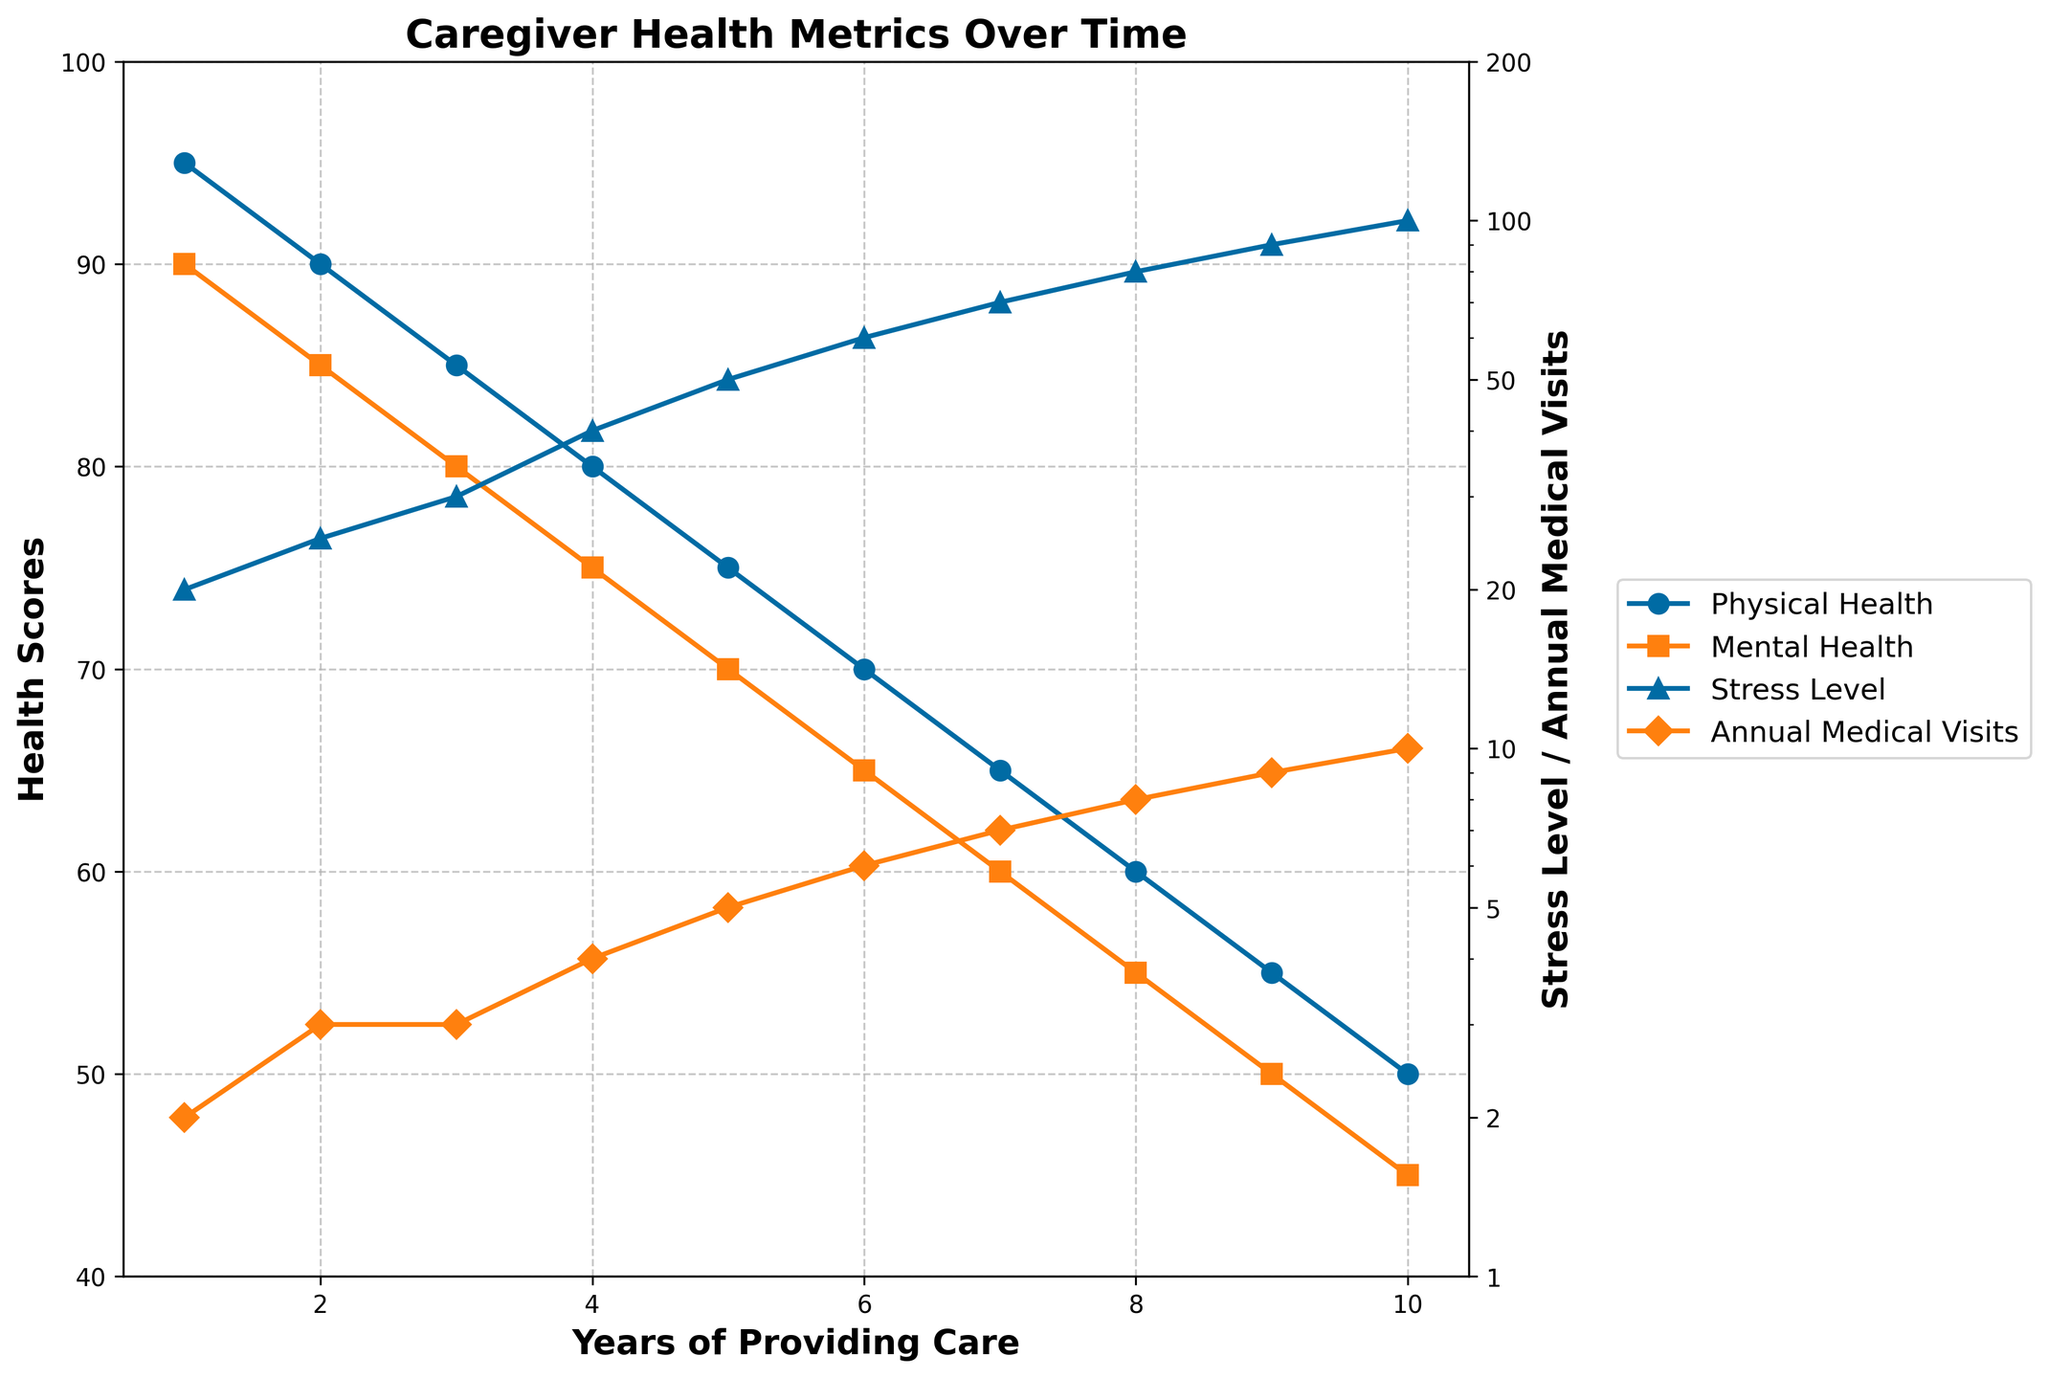What is the title of the plot? The title of the plot is shown at the top of the figure.
Answer: Caregiver Health Metrics Over Time Which health metric decreases more sharply over the years, Physical Health Score or Mental Health Score? Compare the slope of the lines for Physical Health Score and Mental Health Score; the Physical Health Score line appears to be steeper.
Answer: Physical Health Score At what year does the Stress Level reach 50? Look for the year when the Stress Level line reaches the value 50 on the vertical log scale axis.
Answer: Year 5 How many annual medical visits does the caregiver have at year 7? Find the value on the Annual Medical Visits line corresponding to year 7.
Answer: 7 visits What is the range of the Physical Health Score over the 10 years? Identify the highest and lowest values of the Physical Health Score and calculate the difference.
Answer: 45 By year 8, how much has the Mental Health Score decreased since year 1? Calculate the difference between the Mental Health Score at year 1 and year 8.
Answer: 35 points Compare the rates of increase in Stress Level and Annual Medical Visits from year 1 to year 10. Which is steeper? Look at the slopes of both the Stress Level and Annual Medical Visits lines; the point densities provide a visual cue.
Answer: Stress Level What is the correlation between the increase in annual medical visits and stress level? Observe the lines for Annual Medical Visits and Stress Level; since both increase together, they show a positive correlation.
Answer: Positive correlation At what point in the graph do both the Physical Health Score and the Mental Health Score intersect, if at all? Check if there is any point where the lines for Physical Health Score and Mental Health Score cross each other; they do not intersect.
Answer: Never intersect 